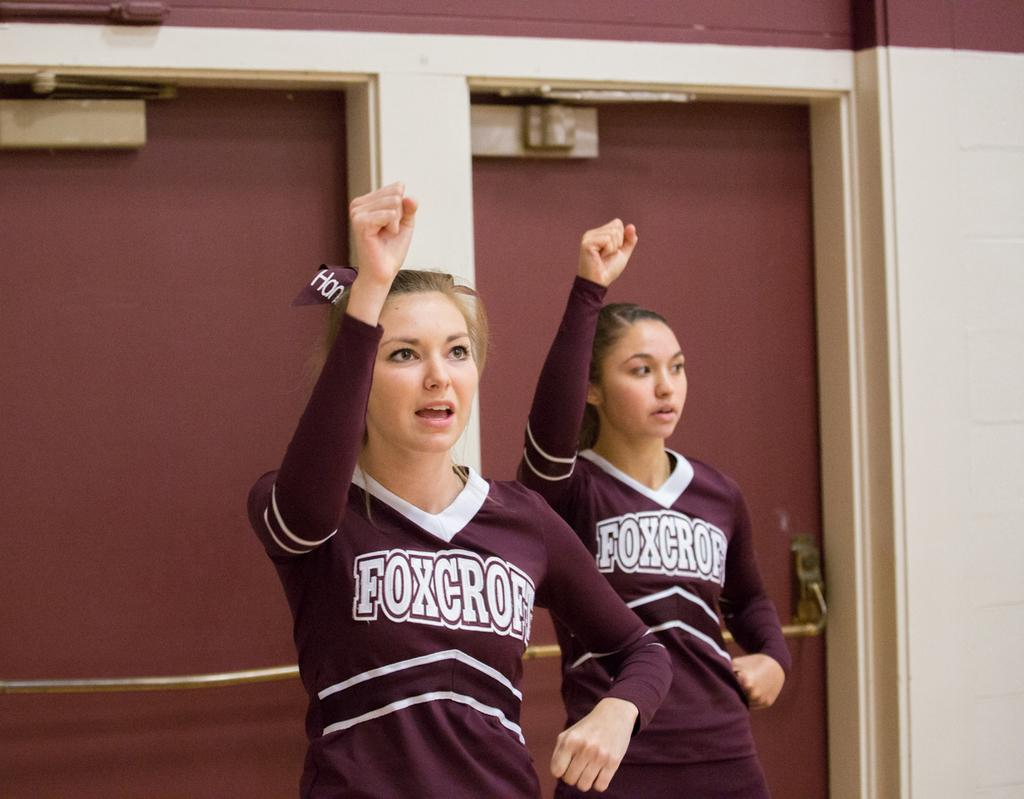<image>
Describe the image concisely. Froxcroft cheerleaders are raising their right hand up. 